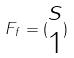<formula> <loc_0><loc_0><loc_500><loc_500>F _ { f } = ( \begin{matrix} s \\ 1 \end{matrix} )</formula> 